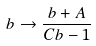<formula> <loc_0><loc_0><loc_500><loc_500>b \to \frac { b + A } { C b - 1 }</formula> 